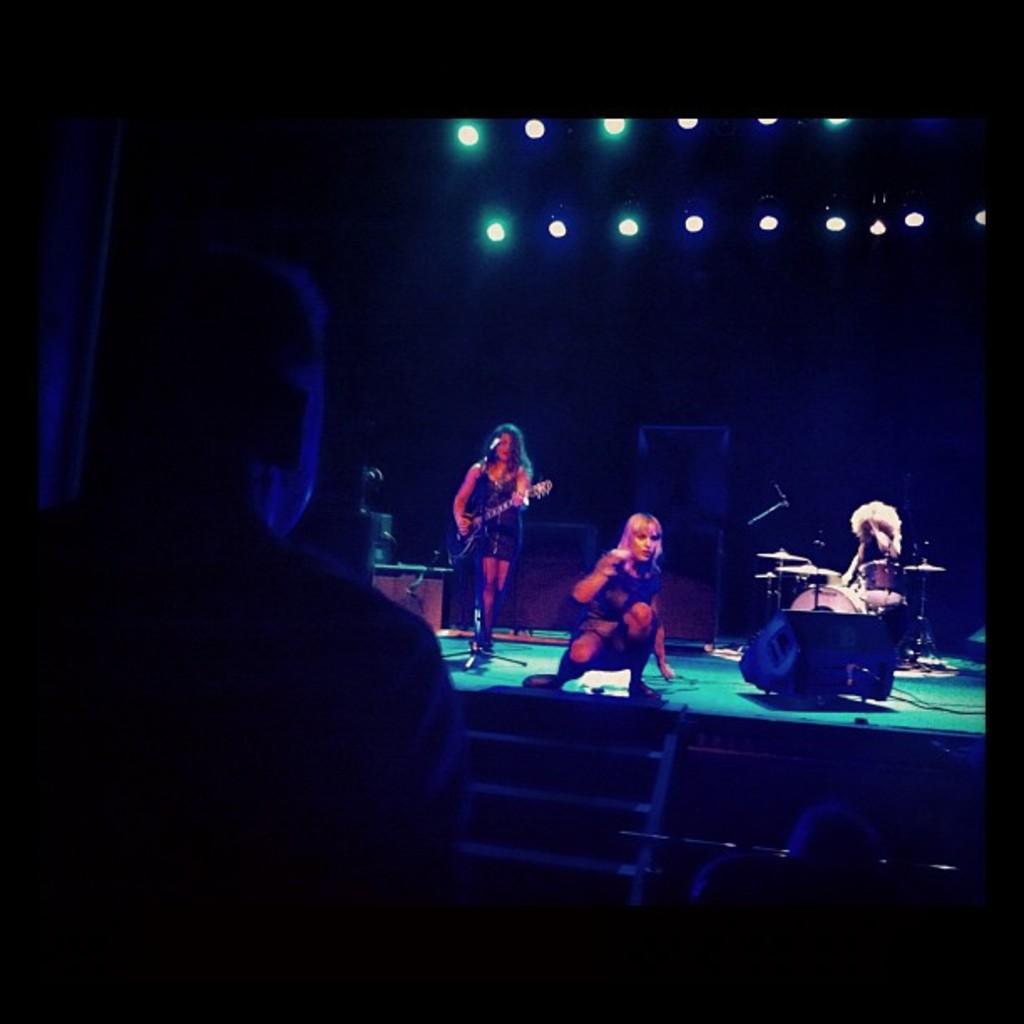In one or two sentences, can you explain what this image depicts? In the background we can see the lights, musical instruments. In this picture we can see the people playing musical instruments and a woman is on the platform, it look like she is performing. In this picture we can see few other objects. Bottom portion of the picture is completely dark and a person is visible. 